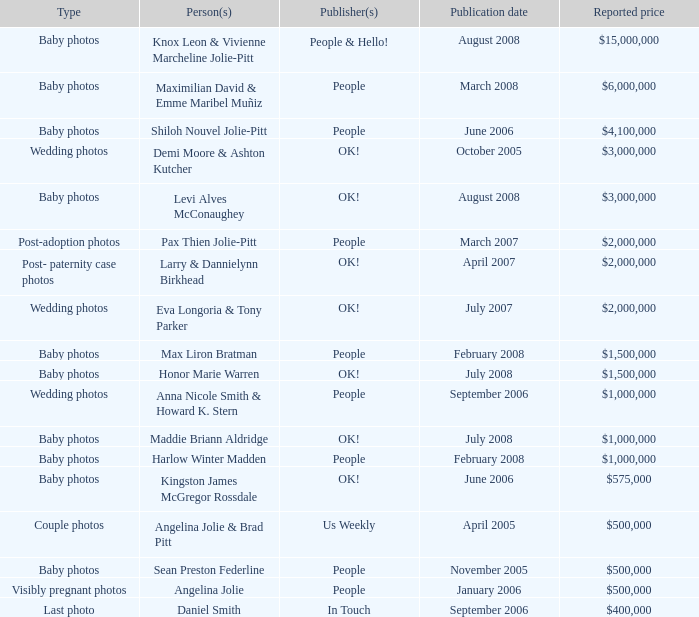What was the publication date of the photos of Sean Preston Federline that cost $500,000 and were published by People? November 2005. Would you mind parsing the complete table? {'header': ['Type', 'Person(s)', 'Publisher(s)', 'Publication date', 'Reported price'], 'rows': [['Baby photos', 'Knox Leon & Vivienne Marcheline Jolie-Pitt', 'People & Hello!', 'August 2008', '$15,000,000'], ['Baby photos', 'Maximilian David & Emme Maribel Muñiz', 'People', 'March 2008', '$6,000,000'], ['Baby photos', 'Shiloh Nouvel Jolie-Pitt', 'People', 'June 2006', '$4,100,000'], ['Wedding photos', 'Demi Moore & Ashton Kutcher', 'OK!', 'October 2005', '$3,000,000'], ['Baby photos', 'Levi Alves McConaughey', 'OK!', 'August 2008', '$3,000,000'], ['Post-adoption photos', 'Pax Thien Jolie-Pitt', 'People', 'March 2007', '$2,000,000'], ['Post- paternity case photos', 'Larry & Dannielynn Birkhead', 'OK!', 'April 2007', '$2,000,000'], ['Wedding photos', 'Eva Longoria & Tony Parker', 'OK!', 'July 2007', '$2,000,000'], ['Baby photos', 'Max Liron Bratman', 'People', 'February 2008', '$1,500,000'], ['Baby photos', 'Honor Marie Warren', 'OK!', 'July 2008', '$1,500,000'], ['Wedding photos', 'Anna Nicole Smith & Howard K. Stern', 'People', 'September 2006', '$1,000,000'], ['Baby photos', 'Maddie Briann Aldridge', 'OK!', 'July 2008', '$1,000,000'], ['Baby photos', 'Harlow Winter Madden', 'People', 'February 2008', '$1,000,000'], ['Baby photos', 'Kingston James McGregor Rossdale', 'OK!', 'June 2006', '$575,000'], ['Couple photos', 'Angelina Jolie & Brad Pitt', 'Us Weekly', 'April 2005', '$500,000'], ['Baby photos', 'Sean Preston Federline', 'People', 'November 2005', '$500,000'], ['Visibly pregnant photos', 'Angelina Jolie', 'People', 'January 2006', '$500,000'], ['Last photo', 'Daniel Smith', 'In Touch', 'September 2006', '$400,000']]} 